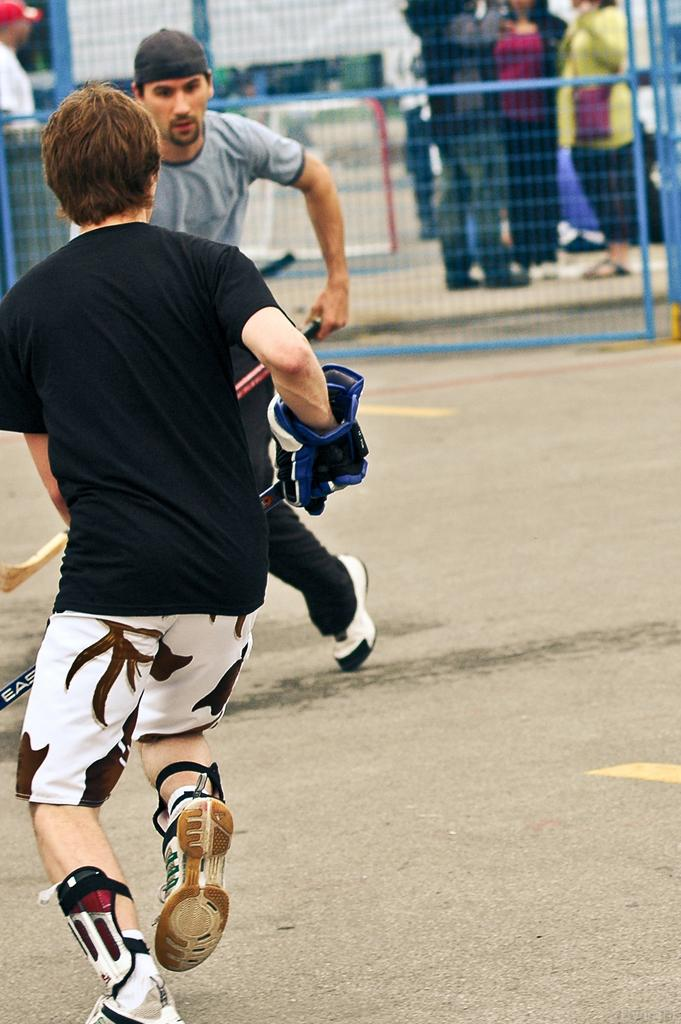What are the two persons in the image doing? The two persons in the image are playing hockey. What is located at the bottom of the image? There is a road at the bottom of the image. What can be seen in the background of the image? There is a fencing in the background of the image. What is happening behind the fencing? There are many people standing behind the fencing. Can you see any grapes growing on the road in the image? There are no grapes visible in the image, and the road is not a suitable environment for grape growth. 